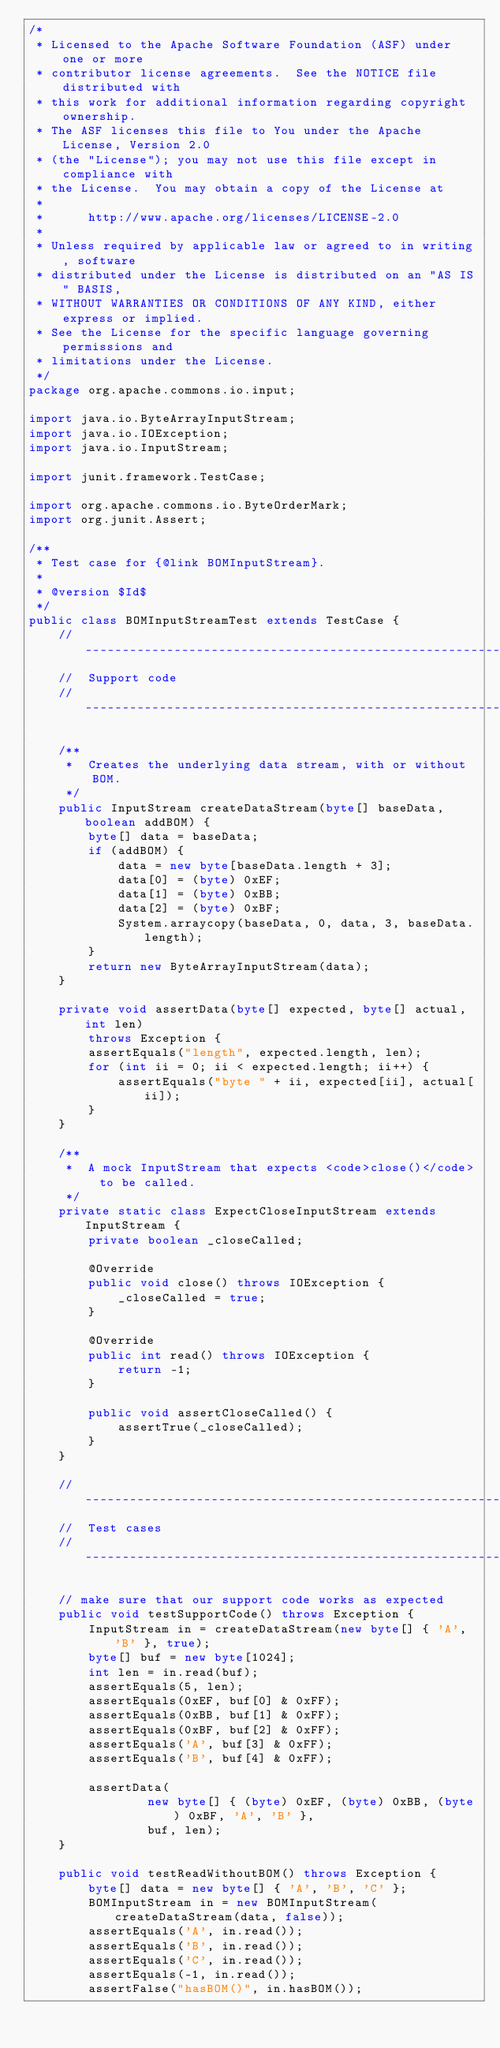Convert code to text. <code><loc_0><loc_0><loc_500><loc_500><_Java_>/*
 * Licensed to the Apache Software Foundation (ASF) under one or more
 * contributor license agreements.  See the NOTICE file distributed with
 * this work for additional information regarding copyright ownership.
 * The ASF licenses this file to You under the Apache License, Version 2.0
 * (the "License"); you may not use this file except in compliance with
 * the License.  You may obtain a copy of the License at
 * 
 *      http://www.apache.org/licenses/LICENSE-2.0
 * 
 * Unless required by applicable law or agreed to in writing, software
 * distributed under the License is distributed on an "AS IS" BASIS,
 * WITHOUT WARRANTIES OR CONDITIONS OF ANY KIND, either express or implied.
 * See the License for the specific language governing permissions and
 * limitations under the License.
 */
package org.apache.commons.io.input;

import java.io.ByteArrayInputStream;
import java.io.IOException;
import java.io.InputStream;

import junit.framework.TestCase;

import org.apache.commons.io.ByteOrderMark;
import org.junit.Assert;

/**
 * Test case for {@link BOMInputStream}.
 *
 * @version $Id$
 */
public class BOMInputStreamTest extends TestCase {
    //----------------------------------------------------------------------------
    //  Support code
    //----------------------------------------------------------------------------

    /**
     *  Creates the underlying data stream, with or without BOM.
     */
    public InputStream createDataStream(byte[] baseData, boolean addBOM) {
        byte[] data = baseData;
        if (addBOM) {
            data = new byte[baseData.length + 3];
            data[0] = (byte) 0xEF;
            data[1] = (byte) 0xBB;
            data[2] = (byte) 0xBF;
            System.arraycopy(baseData, 0, data, 3, baseData.length);
        }
        return new ByteArrayInputStream(data);
    }

    private void assertData(byte[] expected, byte[] actual, int len)
        throws Exception {
        assertEquals("length", expected.length, len);
        for (int ii = 0; ii < expected.length; ii++) {
            assertEquals("byte " + ii, expected[ii], actual[ii]);
        }
    }

    /**
     *  A mock InputStream that expects <code>close()</code> to be called.
     */
    private static class ExpectCloseInputStream extends InputStream {
        private boolean _closeCalled;

        @Override
        public void close() throws IOException {
            _closeCalled = true;
        }

        @Override
        public int read() throws IOException {
            return -1;
        }

        public void assertCloseCalled() {
            assertTrue(_closeCalled);
        }
    }

    //----------------------------------------------------------------------------
    //  Test cases
    //----------------------------------------------------------------------------

    // make sure that our support code works as expected
    public void testSupportCode() throws Exception {
        InputStream in = createDataStream(new byte[] { 'A', 'B' }, true);
        byte[] buf = new byte[1024];
        int len = in.read(buf);
        assertEquals(5, len);
        assertEquals(0xEF, buf[0] & 0xFF);
        assertEquals(0xBB, buf[1] & 0xFF);
        assertEquals(0xBF, buf[2] & 0xFF);
        assertEquals('A', buf[3] & 0xFF);
        assertEquals('B', buf[4] & 0xFF);

        assertData(
                new byte[] { (byte) 0xEF, (byte) 0xBB, (byte) 0xBF, 'A', 'B' },
                buf, len);
    }

    public void testReadWithoutBOM() throws Exception {
        byte[] data = new byte[] { 'A', 'B', 'C' };
        BOMInputStream in = new BOMInputStream(createDataStream(data, false));
        assertEquals('A', in.read());
        assertEquals('B', in.read());
        assertEquals('C', in.read());
        assertEquals(-1, in.read());
        assertFalse("hasBOM()", in.hasBOM());</code> 